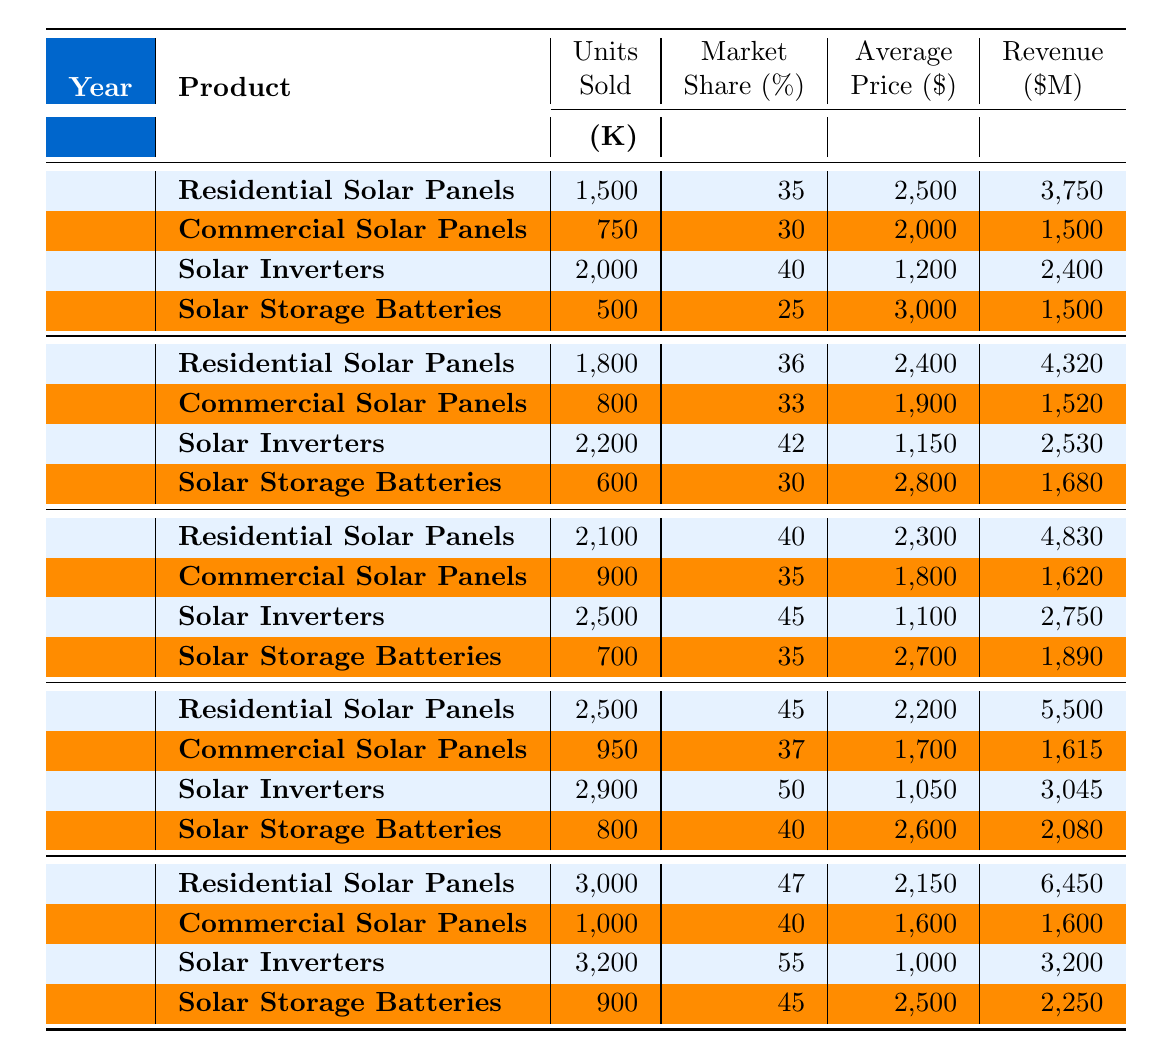What was the total revenue from Residential Solar Panels in 2022? For Residential Solar Panels in 2022, the revenue is listed as 5,500 million dollars.
Answer: 5,500 million dollars Which product had the highest market share in 2023? In 2023, Solar Inverters had the highest market share at 55%.
Answer: Solar Inverters How many units of Solar Storage Batteries were sold in 2020? The table shows that 600,000 units of Solar Storage Batteries were sold in 2020.
Answer: 600,000 units What is the average price of Commercial Solar Panels over the five-year period? The average price is calculated by taking the sum of the average prices from 2019 to 2023 (2000 + 1900 + 1800 + 1700 + 1600) = 11000, dividing by 5 gives an average price of 2200.
Answer: 2200 Did the units sold for Residential Solar Panels increase every year from 2019 to 2023? Yes, the units sold increased each year: 1,500,000 (2019), 1,800,000 (2020), 2,100,000 (2021), 2,500,000 (2022), and 3,000,000 (2023).
Answer: Yes What was the percentage increase in units sold of Solar Inverters from 2019 to 2023? The units sold for Solar Inverters increased from 2,000,000 in 2019 to 3,200,000 in 2023. The increase is 3,200,000 - 2,000,000 = 1,200,000. The percentage increase is (1,200,000 / 2,000,000) * 100 = 60%.
Answer: 60% Calculate the total revenue from all products sold in 2021. The total revenue from all products in 2021 is calculated by summing the revenues: 4,830 (Residential) + 1,620 (Commercial) + 2,750 (Inverters) + 1,890 (Batteries) = 12,090 million dollars.
Answer: 12,090 million dollars Which year saw the highest sales of Solar Inverters? In 2023, the sales of Solar Inverters reached 3,200,000, the highest in the data.
Answer: 2023 How much revenue did the Commercial Solar Panels generate in total from 2019 to 2023? The total revenue for Commercial Solar Panels is calculated by summing their annual revenues: 1,500 (2019) + 1,520 (2020) + 1,620 (2021) + 1,615 (2022) + 1,600 (2023) = 7,875 million dollars.
Answer: 7,875 million dollars Is it true that the average price of Solar Storage Batteries decreased from 2019 to 2023? The average prices for Solar Storage Batteries are 3,000 (2019), 2,800 (2020), 2,700 (2021), 2,600 (2022), and 2,500 (2023). Since the prices are consistently decreasing, the statement is true.
Answer: Yes 